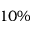<formula> <loc_0><loc_0><loc_500><loc_500>1 0 \%</formula> 